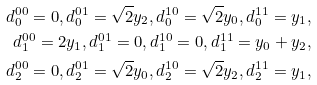<formula> <loc_0><loc_0><loc_500><loc_500>d _ { 0 } ^ { 0 0 } = 0 , d _ { 0 } ^ { 0 1 } = \sqrt { 2 } y _ { 2 } , d _ { 0 } ^ { 1 0 } = \sqrt { 2 } y _ { 0 } , d _ { 0 } ^ { 1 1 } = y _ { 1 } , \\ d _ { 1 } ^ { 0 0 } = 2 y _ { 1 } , d _ { 1 } ^ { 0 1 } = 0 , d _ { 1 } ^ { 1 0 } = 0 , d _ { 1 } ^ { 1 1 } = y _ { 0 } + y _ { 2 } , \\ d _ { 2 } ^ { 0 0 } = 0 , d _ { 2 } ^ { 0 1 } = \sqrt { 2 } y _ { 0 } , d _ { 2 } ^ { 1 0 } = \sqrt { 2 } y _ { 2 } , d _ { 2 } ^ { 1 1 } = y _ { 1 } , \\</formula> 